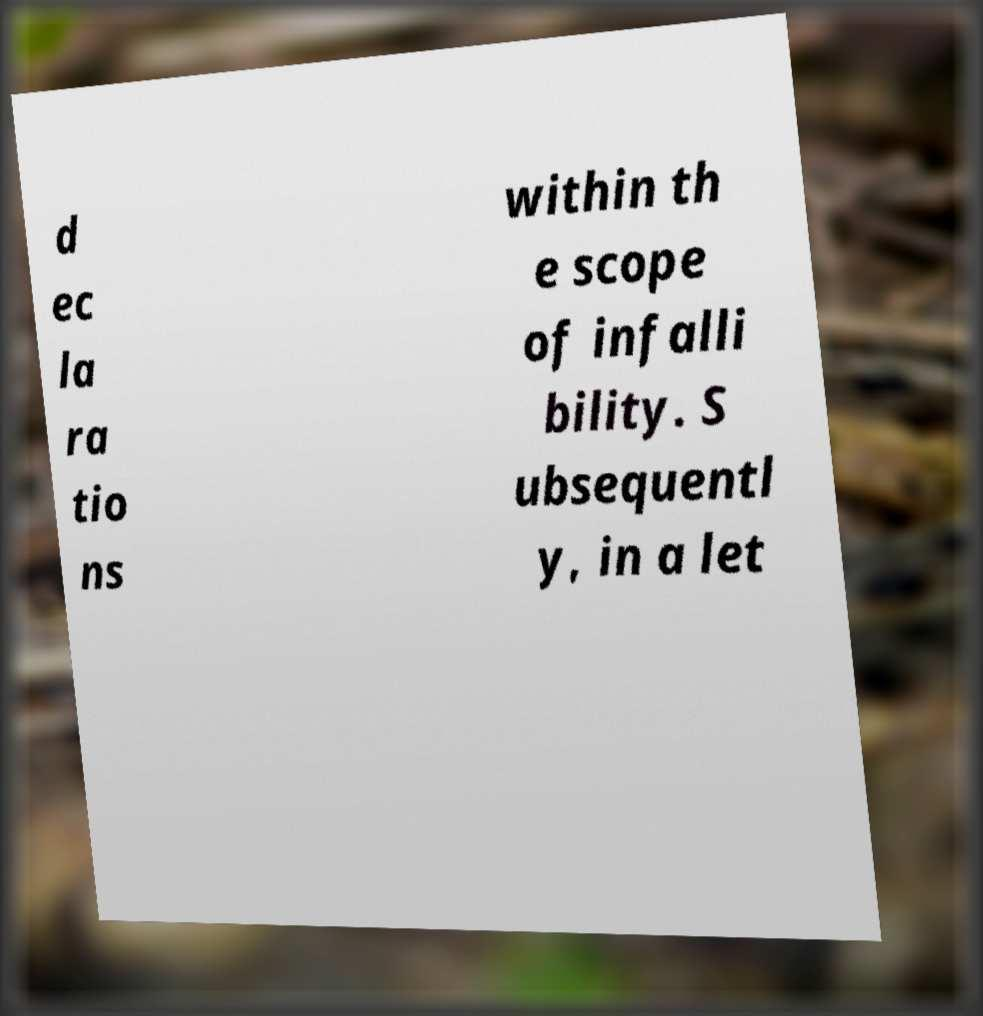There's text embedded in this image that I need extracted. Can you transcribe it verbatim? d ec la ra tio ns within th e scope of infalli bility. S ubsequentl y, in a let 